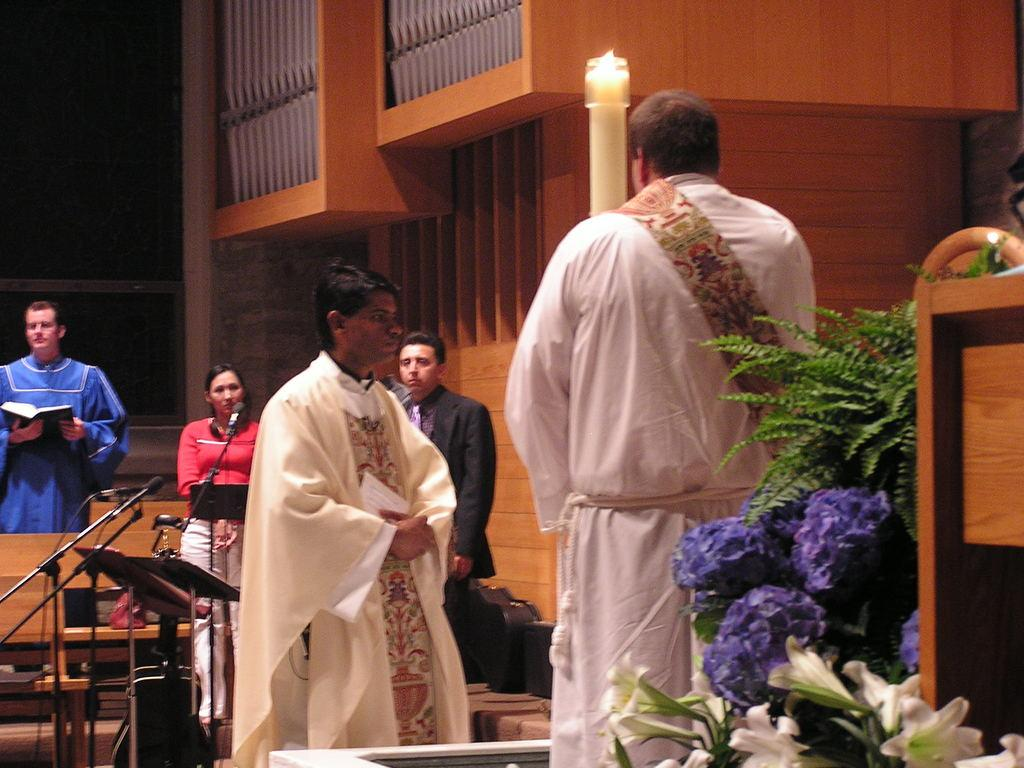What are the people in the image doing? The people in the image are standing and holding books. What can be seen on the wall in the image? There is a wall in the image, but no specific details are provided about what is on the wall. What type of vegetation is present in the image? There are flowers in the image. What type of lettuce is being used as a bookmark in the image? There is no lettuce present in the image, and no bookmarks are visible. Can you tell me how many fish are swimming in the flowers in the image? There are no fish present in the image, and the flowers are not depicted as an aquatic environment. 